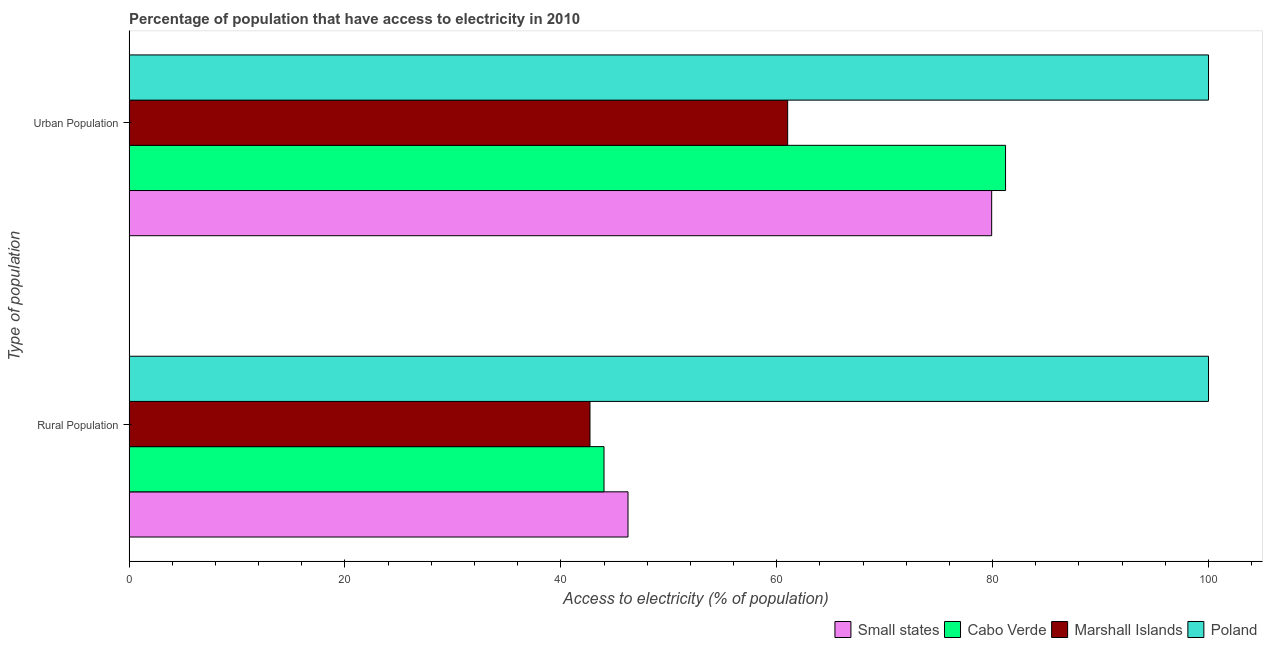Are the number of bars on each tick of the Y-axis equal?
Offer a very short reply. Yes. How many bars are there on the 1st tick from the top?
Keep it short and to the point. 4. How many bars are there on the 1st tick from the bottom?
Offer a terse response. 4. What is the label of the 1st group of bars from the top?
Keep it short and to the point. Urban Population. Across all countries, what is the maximum percentage of urban population having access to electricity?
Your answer should be very brief. 100. Across all countries, what is the minimum percentage of urban population having access to electricity?
Offer a terse response. 61.01. In which country was the percentage of urban population having access to electricity maximum?
Provide a succinct answer. Poland. In which country was the percentage of urban population having access to electricity minimum?
Ensure brevity in your answer.  Marshall Islands. What is the total percentage of rural population having access to electricity in the graph?
Your answer should be compact. 232.92. What is the difference between the percentage of rural population having access to electricity in Cabo Verde and that in Small states?
Your response must be concise. -2.22. What is the difference between the percentage of urban population having access to electricity in Poland and the percentage of rural population having access to electricity in Small states?
Your answer should be very brief. 53.78. What is the average percentage of urban population having access to electricity per country?
Make the answer very short. 80.53. What is the ratio of the percentage of rural population having access to electricity in Small states to that in Marshall Islands?
Provide a succinct answer. 1.08. Is the percentage of urban population having access to electricity in Cabo Verde less than that in Poland?
Provide a succinct answer. Yes. What does the 2nd bar from the bottom in Rural Population represents?
Provide a short and direct response. Cabo Verde. How many bars are there?
Your answer should be compact. 8. How many countries are there in the graph?
Offer a very short reply. 4. Are the values on the major ticks of X-axis written in scientific E-notation?
Your response must be concise. No. Does the graph contain grids?
Give a very brief answer. No. What is the title of the graph?
Provide a succinct answer. Percentage of population that have access to electricity in 2010. What is the label or title of the X-axis?
Provide a short and direct response. Access to electricity (% of population). What is the label or title of the Y-axis?
Offer a very short reply. Type of population. What is the Access to electricity (% of population) of Small states in Rural Population?
Your response must be concise. 46.22. What is the Access to electricity (% of population) of Marshall Islands in Rural Population?
Offer a very short reply. 42.7. What is the Access to electricity (% of population) in Poland in Rural Population?
Provide a short and direct response. 100. What is the Access to electricity (% of population) of Small states in Urban Population?
Offer a terse response. 79.91. What is the Access to electricity (% of population) of Cabo Verde in Urban Population?
Offer a very short reply. 81.2. What is the Access to electricity (% of population) of Marshall Islands in Urban Population?
Your answer should be very brief. 61.01. What is the Access to electricity (% of population) of Poland in Urban Population?
Your answer should be compact. 100. Across all Type of population, what is the maximum Access to electricity (% of population) in Small states?
Keep it short and to the point. 79.91. Across all Type of population, what is the maximum Access to electricity (% of population) in Cabo Verde?
Your response must be concise. 81.2. Across all Type of population, what is the maximum Access to electricity (% of population) of Marshall Islands?
Make the answer very short. 61.01. Across all Type of population, what is the minimum Access to electricity (% of population) in Small states?
Your answer should be compact. 46.22. Across all Type of population, what is the minimum Access to electricity (% of population) of Cabo Verde?
Give a very brief answer. 44. Across all Type of population, what is the minimum Access to electricity (% of population) of Marshall Islands?
Give a very brief answer. 42.7. Across all Type of population, what is the minimum Access to electricity (% of population) in Poland?
Provide a succinct answer. 100. What is the total Access to electricity (% of population) in Small states in the graph?
Offer a terse response. 126.14. What is the total Access to electricity (% of population) in Cabo Verde in the graph?
Give a very brief answer. 125.2. What is the total Access to electricity (% of population) of Marshall Islands in the graph?
Ensure brevity in your answer.  103.71. What is the difference between the Access to electricity (% of population) of Small states in Rural Population and that in Urban Population?
Provide a succinct answer. -33.69. What is the difference between the Access to electricity (% of population) of Cabo Verde in Rural Population and that in Urban Population?
Offer a terse response. -37.2. What is the difference between the Access to electricity (% of population) of Marshall Islands in Rural Population and that in Urban Population?
Make the answer very short. -18.31. What is the difference between the Access to electricity (% of population) in Small states in Rural Population and the Access to electricity (% of population) in Cabo Verde in Urban Population?
Your response must be concise. -34.97. What is the difference between the Access to electricity (% of population) in Small states in Rural Population and the Access to electricity (% of population) in Marshall Islands in Urban Population?
Provide a short and direct response. -14.79. What is the difference between the Access to electricity (% of population) in Small states in Rural Population and the Access to electricity (% of population) in Poland in Urban Population?
Provide a short and direct response. -53.78. What is the difference between the Access to electricity (% of population) in Cabo Verde in Rural Population and the Access to electricity (% of population) in Marshall Islands in Urban Population?
Your answer should be compact. -17.01. What is the difference between the Access to electricity (% of population) of Cabo Verde in Rural Population and the Access to electricity (% of population) of Poland in Urban Population?
Your answer should be compact. -56. What is the difference between the Access to electricity (% of population) of Marshall Islands in Rural Population and the Access to electricity (% of population) of Poland in Urban Population?
Make the answer very short. -57.3. What is the average Access to electricity (% of population) in Small states per Type of population?
Offer a very short reply. 63.07. What is the average Access to electricity (% of population) in Cabo Verde per Type of population?
Your answer should be very brief. 62.6. What is the average Access to electricity (% of population) in Marshall Islands per Type of population?
Give a very brief answer. 51.86. What is the average Access to electricity (% of population) in Poland per Type of population?
Provide a short and direct response. 100. What is the difference between the Access to electricity (% of population) in Small states and Access to electricity (% of population) in Cabo Verde in Rural Population?
Provide a succinct answer. 2.22. What is the difference between the Access to electricity (% of population) of Small states and Access to electricity (% of population) of Marshall Islands in Rural Population?
Provide a succinct answer. 3.52. What is the difference between the Access to electricity (% of population) of Small states and Access to electricity (% of population) of Poland in Rural Population?
Your response must be concise. -53.78. What is the difference between the Access to electricity (% of population) of Cabo Verde and Access to electricity (% of population) of Marshall Islands in Rural Population?
Your answer should be very brief. 1.3. What is the difference between the Access to electricity (% of population) of Cabo Verde and Access to electricity (% of population) of Poland in Rural Population?
Your answer should be compact. -56. What is the difference between the Access to electricity (% of population) of Marshall Islands and Access to electricity (% of population) of Poland in Rural Population?
Offer a terse response. -57.3. What is the difference between the Access to electricity (% of population) in Small states and Access to electricity (% of population) in Cabo Verde in Urban Population?
Your answer should be compact. -1.28. What is the difference between the Access to electricity (% of population) in Small states and Access to electricity (% of population) in Marshall Islands in Urban Population?
Your answer should be compact. 18.9. What is the difference between the Access to electricity (% of population) of Small states and Access to electricity (% of population) of Poland in Urban Population?
Keep it short and to the point. -20.09. What is the difference between the Access to electricity (% of population) in Cabo Verde and Access to electricity (% of population) in Marshall Islands in Urban Population?
Offer a terse response. 20.18. What is the difference between the Access to electricity (% of population) of Cabo Verde and Access to electricity (% of population) of Poland in Urban Population?
Offer a very short reply. -18.8. What is the difference between the Access to electricity (% of population) of Marshall Islands and Access to electricity (% of population) of Poland in Urban Population?
Ensure brevity in your answer.  -38.99. What is the ratio of the Access to electricity (% of population) of Small states in Rural Population to that in Urban Population?
Your answer should be compact. 0.58. What is the ratio of the Access to electricity (% of population) of Cabo Verde in Rural Population to that in Urban Population?
Offer a very short reply. 0.54. What is the ratio of the Access to electricity (% of population) of Marshall Islands in Rural Population to that in Urban Population?
Keep it short and to the point. 0.7. What is the difference between the highest and the second highest Access to electricity (% of population) in Small states?
Your answer should be very brief. 33.69. What is the difference between the highest and the second highest Access to electricity (% of population) in Cabo Verde?
Provide a short and direct response. 37.2. What is the difference between the highest and the second highest Access to electricity (% of population) in Marshall Islands?
Make the answer very short. 18.31. What is the difference between the highest and the second highest Access to electricity (% of population) of Poland?
Ensure brevity in your answer.  0. What is the difference between the highest and the lowest Access to electricity (% of population) in Small states?
Provide a succinct answer. 33.69. What is the difference between the highest and the lowest Access to electricity (% of population) in Cabo Verde?
Provide a succinct answer. 37.2. What is the difference between the highest and the lowest Access to electricity (% of population) of Marshall Islands?
Ensure brevity in your answer.  18.31. 